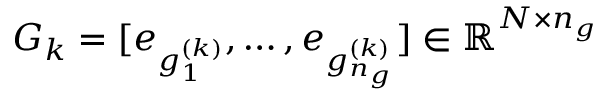Convert formula to latex. <formula><loc_0><loc_0><loc_500><loc_500>G _ { k } = [ e _ { g _ { 1 } ^ { ( k ) } } , \dots , e _ { g _ { n _ { g } } ^ { ( k ) } } ] \in \mathbb { R } ^ { N \times n _ { g } }</formula> 